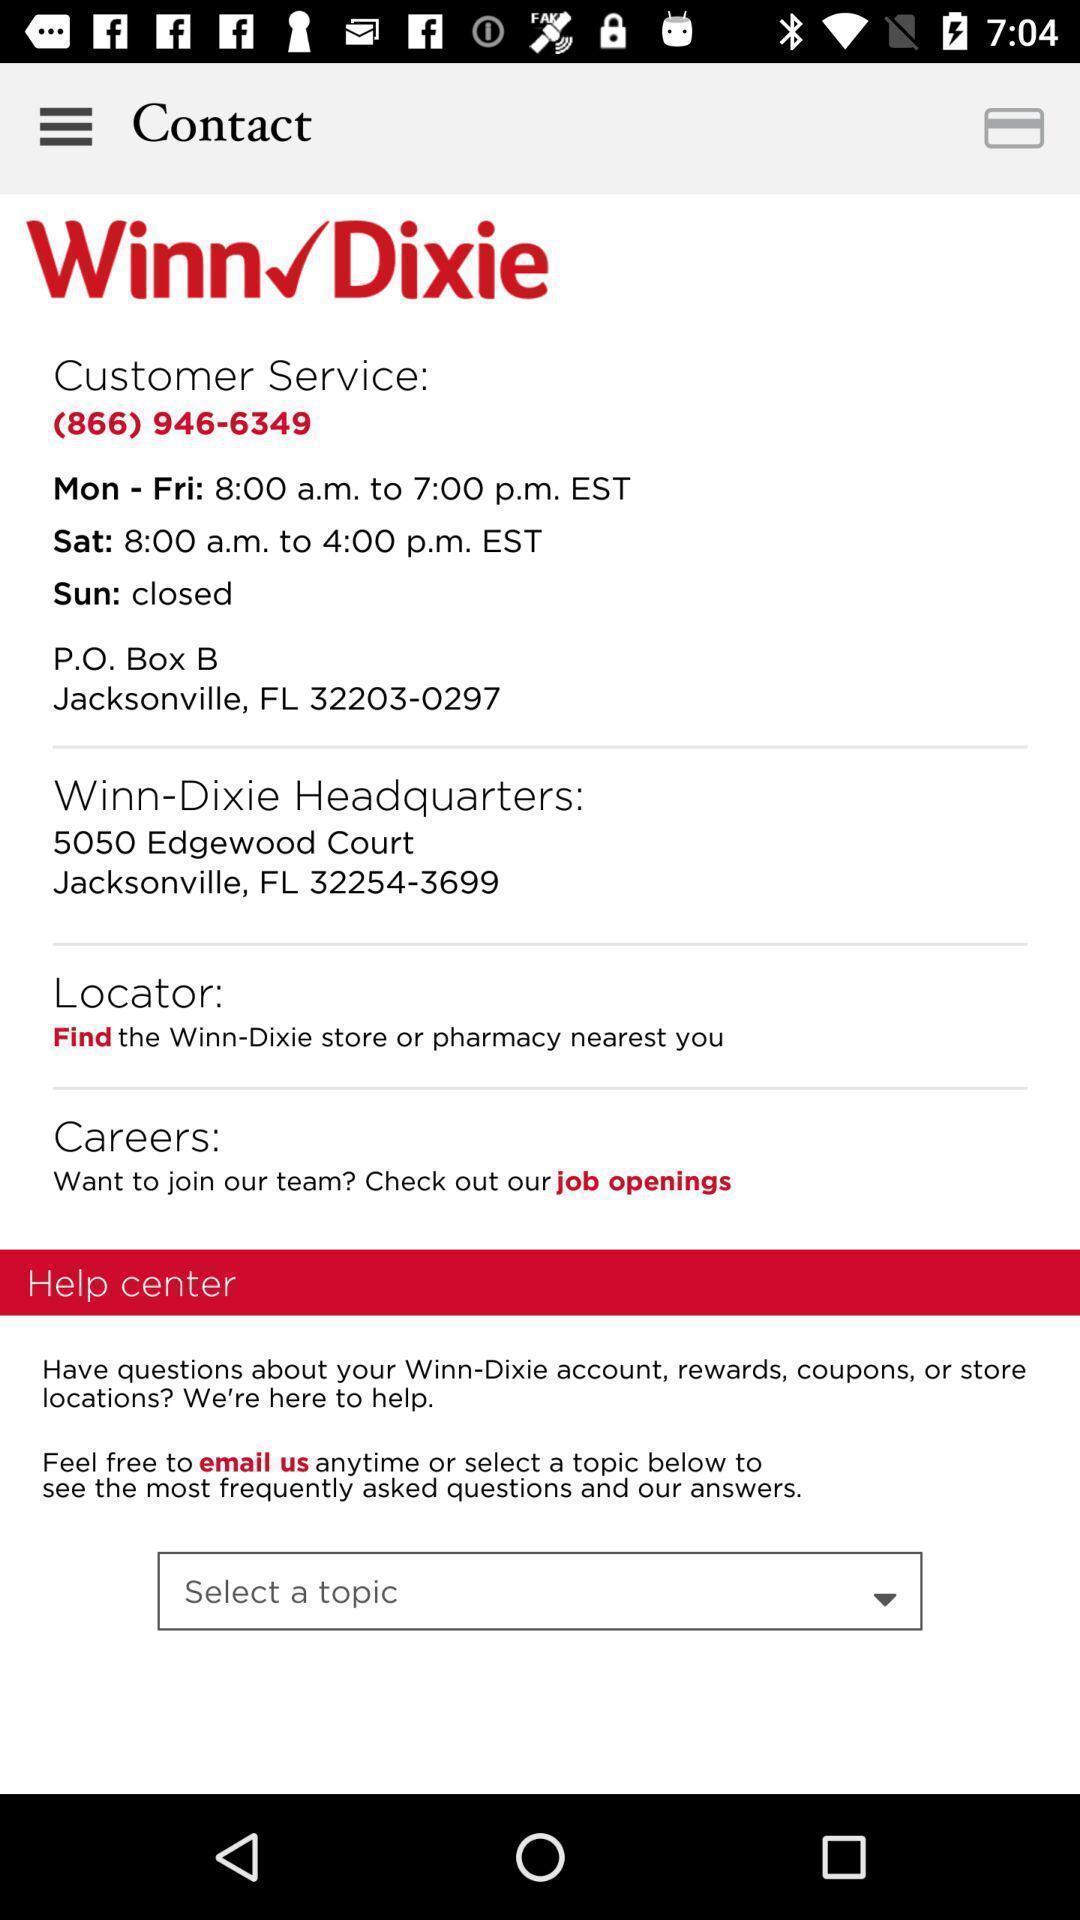Explain what's happening in this screen capture. Screen displaying contact details. 